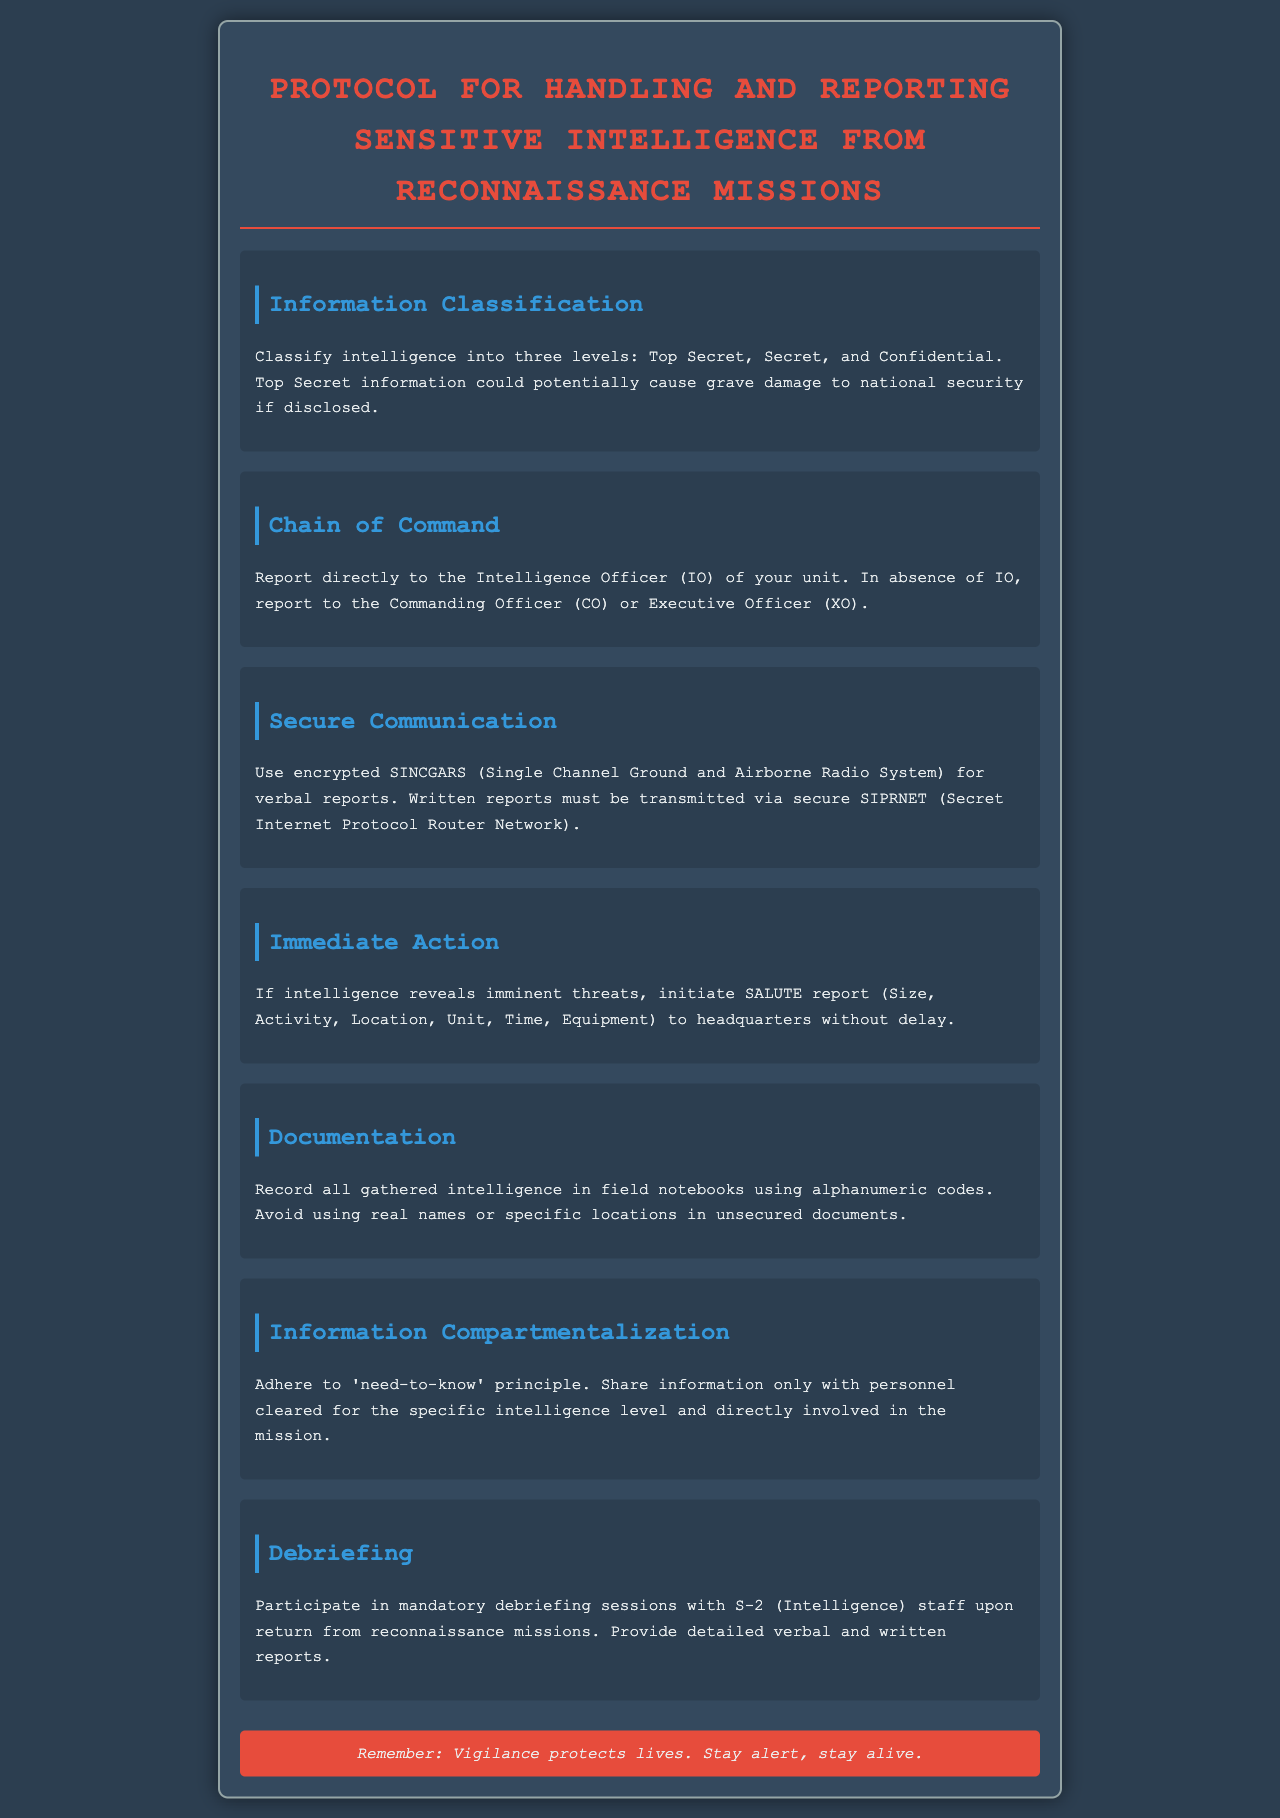What are the three levels of intelligence classification? The document lists the levels of intelligence classification as Top Secret, Secret, and Confidential.
Answer: Top Secret, Secret, Confidential Who should intelligence reports be directed to? The report states that intelligence should be reported directly to the Intelligence Officer (IO) of the unit.
Answer: Intelligence Officer (IO) What system is used for verbal reports? The document specifies that encrypted SINCGARS is used for verbal reports.
Answer: SINCGARS What report format should be initiated for imminent threats? It mentions the SALUTE report format that should be used if there are imminent threats.
Answer: SALUTE report What principle should be adhered to for information sharing? The document emphasizes the need-to-know principle for sharing information.
Answer: Need-to-know principle Who conducts mandatory debriefing sessions? The debriefing sessions are conducted with the S-2 (Intelligence) staff upon return from missions.
Answer: S-2 (Intelligence) What should be used in written reports? The document states that written reports must be transmitted via secure SIPRNET.
Answer: SIPRNET What type of codes should be used in field notebooks? It requires that alphanumeric codes be used in field notebooks for documentation.
Answer: Alphanumeric codes 